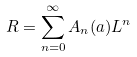Convert formula to latex. <formula><loc_0><loc_0><loc_500><loc_500>R = \sum _ { n = 0 } ^ { \infty } A _ { n } ( a ) L ^ { n }</formula> 